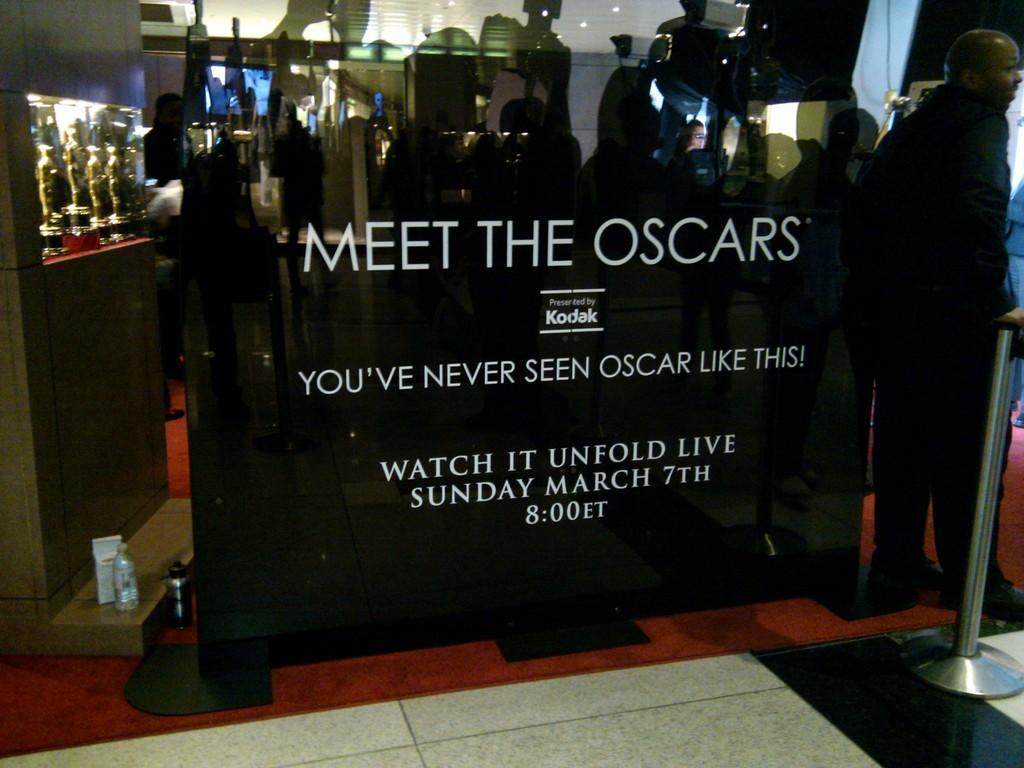Describe this image in one or two sentences. In this picture I can see the banner in the foreground. I can see a number of memento on the left side. I can see a person on the right side. I can see the barrier. 